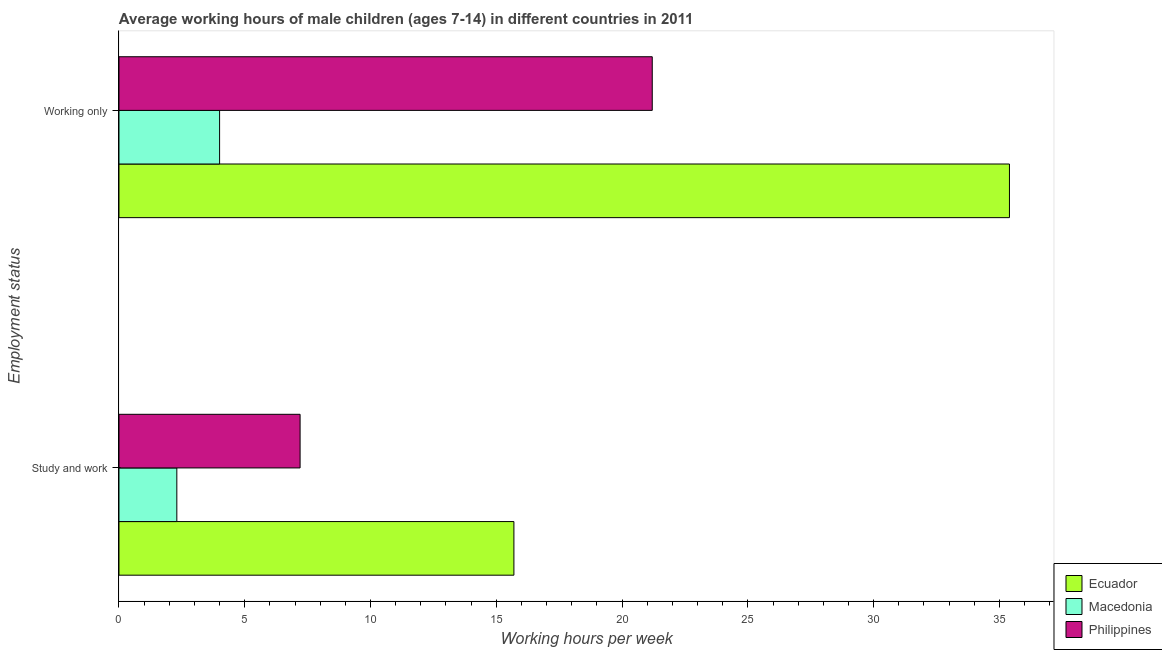How many different coloured bars are there?
Your answer should be compact. 3. Are the number of bars per tick equal to the number of legend labels?
Offer a terse response. Yes. Are the number of bars on each tick of the Y-axis equal?
Provide a short and direct response. Yes. What is the label of the 2nd group of bars from the top?
Give a very brief answer. Study and work. What is the average working hour of children involved in study and work in Philippines?
Offer a very short reply. 7.2. Across all countries, what is the maximum average working hour of children involved in only work?
Give a very brief answer. 35.4. In which country was the average working hour of children involved in study and work maximum?
Your response must be concise. Ecuador. In which country was the average working hour of children involved in only work minimum?
Your answer should be compact. Macedonia. What is the total average working hour of children involved in study and work in the graph?
Offer a terse response. 25.2. What is the difference between the average working hour of children involved in study and work in Philippines and the average working hour of children involved in only work in Ecuador?
Your response must be concise. -28.2. What is the difference between the average working hour of children involved in study and work and average working hour of children involved in only work in Macedonia?
Ensure brevity in your answer.  -1.7. What is the ratio of the average working hour of children involved in study and work in Macedonia to that in Ecuador?
Your answer should be very brief. 0.15. What does the 2nd bar from the top in Study and work represents?
Give a very brief answer. Macedonia. What does the 2nd bar from the bottom in Study and work represents?
Your response must be concise. Macedonia. What is the difference between two consecutive major ticks on the X-axis?
Offer a very short reply. 5. Does the graph contain any zero values?
Keep it short and to the point. No. Does the graph contain grids?
Your answer should be compact. No. How are the legend labels stacked?
Your answer should be very brief. Vertical. What is the title of the graph?
Your answer should be very brief. Average working hours of male children (ages 7-14) in different countries in 2011. What is the label or title of the X-axis?
Your answer should be very brief. Working hours per week. What is the label or title of the Y-axis?
Provide a short and direct response. Employment status. What is the Working hours per week in Ecuador in Study and work?
Offer a very short reply. 15.7. What is the Working hours per week in Macedonia in Study and work?
Make the answer very short. 2.3. What is the Working hours per week of Ecuador in Working only?
Provide a succinct answer. 35.4. What is the Working hours per week in Macedonia in Working only?
Offer a very short reply. 4. What is the Working hours per week of Philippines in Working only?
Offer a very short reply. 21.2. Across all Employment status, what is the maximum Working hours per week of Ecuador?
Give a very brief answer. 35.4. Across all Employment status, what is the maximum Working hours per week in Macedonia?
Give a very brief answer. 4. Across all Employment status, what is the maximum Working hours per week of Philippines?
Make the answer very short. 21.2. Across all Employment status, what is the minimum Working hours per week of Macedonia?
Your response must be concise. 2.3. Across all Employment status, what is the minimum Working hours per week in Philippines?
Offer a terse response. 7.2. What is the total Working hours per week in Ecuador in the graph?
Ensure brevity in your answer.  51.1. What is the total Working hours per week in Philippines in the graph?
Provide a short and direct response. 28.4. What is the difference between the Working hours per week of Ecuador in Study and work and that in Working only?
Your answer should be compact. -19.7. What is the difference between the Working hours per week of Macedonia in Study and work and that in Working only?
Make the answer very short. -1.7. What is the difference between the Working hours per week in Philippines in Study and work and that in Working only?
Make the answer very short. -14. What is the difference between the Working hours per week of Ecuador in Study and work and the Working hours per week of Philippines in Working only?
Ensure brevity in your answer.  -5.5. What is the difference between the Working hours per week in Macedonia in Study and work and the Working hours per week in Philippines in Working only?
Offer a very short reply. -18.9. What is the average Working hours per week of Ecuador per Employment status?
Provide a succinct answer. 25.55. What is the average Working hours per week of Macedonia per Employment status?
Keep it short and to the point. 3.15. What is the average Working hours per week in Philippines per Employment status?
Make the answer very short. 14.2. What is the difference between the Working hours per week in Ecuador and Working hours per week in Macedonia in Study and work?
Keep it short and to the point. 13.4. What is the difference between the Working hours per week of Ecuador and Working hours per week of Philippines in Study and work?
Your response must be concise. 8.5. What is the difference between the Working hours per week of Macedonia and Working hours per week of Philippines in Study and work?
Provide a succinct answer. -4.9. What is the difference between the Working hours per week in Ecuador and Working hours per week in Macedonia in Working only?
Your answer should be very brief. 31.4. What is the difference between the Working hours per week in Ecuador and Working hours per week in Philippines in Working only?
Ensure brevity in your answer.  14.2. What is the difference between the Working hours per week of Macedonia and Working hours per week of Philippines in Working only?
Your answer should be compact. -17.2. What is the ratio of the Working hours per week of Ecuador in Study and work to that in Working only?
Your answer should be very brief. 0.44. What is the ratio of the Working hours per week of Macedonia in Study and work to that in Working only?
Provide a succinct answer. 0.57. What is the ratio of the Working hours per week in Philippines in Study and work to that in Working only?
Your answer should be compact. 0.34. What is the difference between the highest and the second highest Working hours per week of Ecuador?
Provide a succinct answer. 19.7. What is the difference between the highest and the second highest Working hours per week of Macedonia?
Make the answer very short. 1.7. What is the difference between the highest and the lowest Working hours per week in Macedonia?
Your answer should be very brief. 1.7. What is the difference between the highest and the lowest Working hours per week in Philippines?
Offer a terse response. 14. 